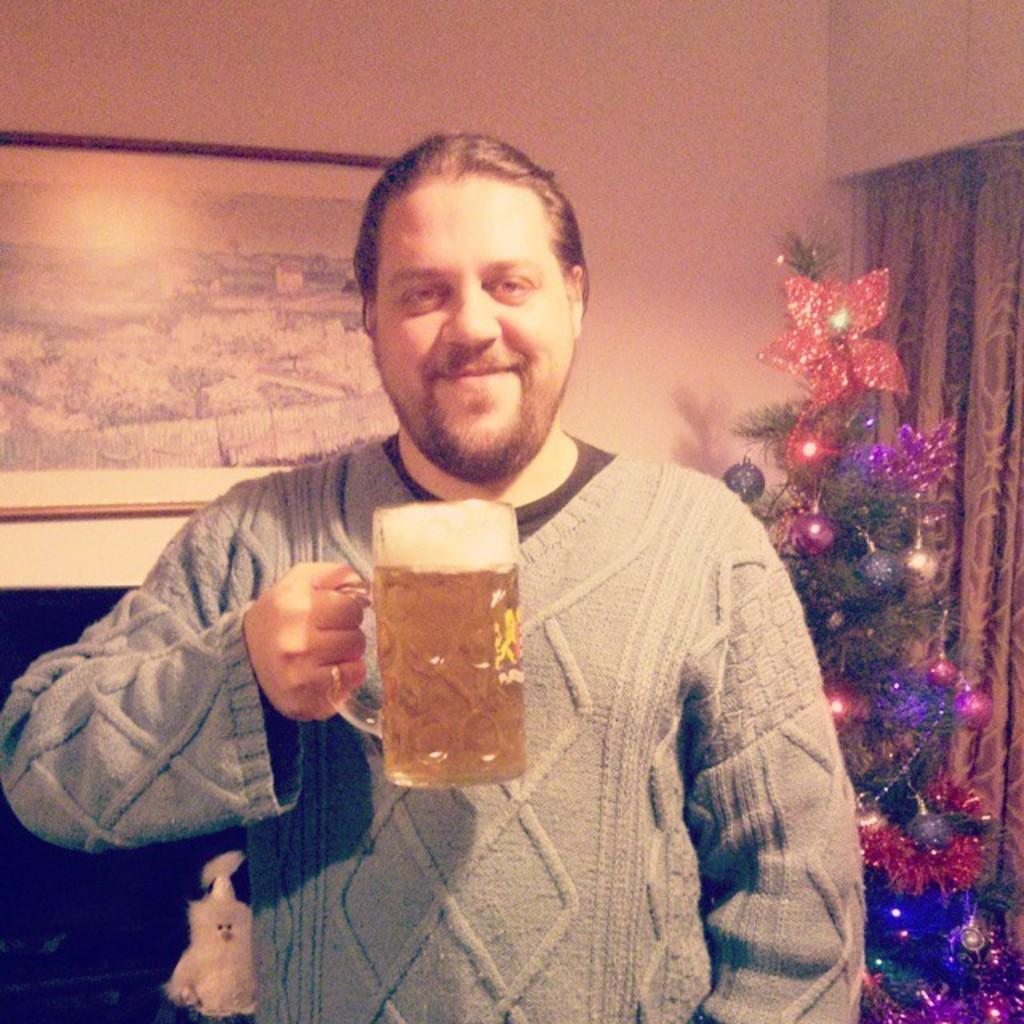Who is present in the image? There is a man in the image. What is the man holding in the image? The man is holding a glass. What can be seen in the background of the image? There is a Christmas tree in the background of the image. How is the frame of the image attached to the wall? The frame is attached to the wall. What type of window treatment is present in the image? There is a curtain in the image. What type of cart is being used to transport the man in the image? There is no cart present in the image; the man is standing. What is the man saying good-bye to in the image? There is no indication of anyone saying good-bye in the image. 